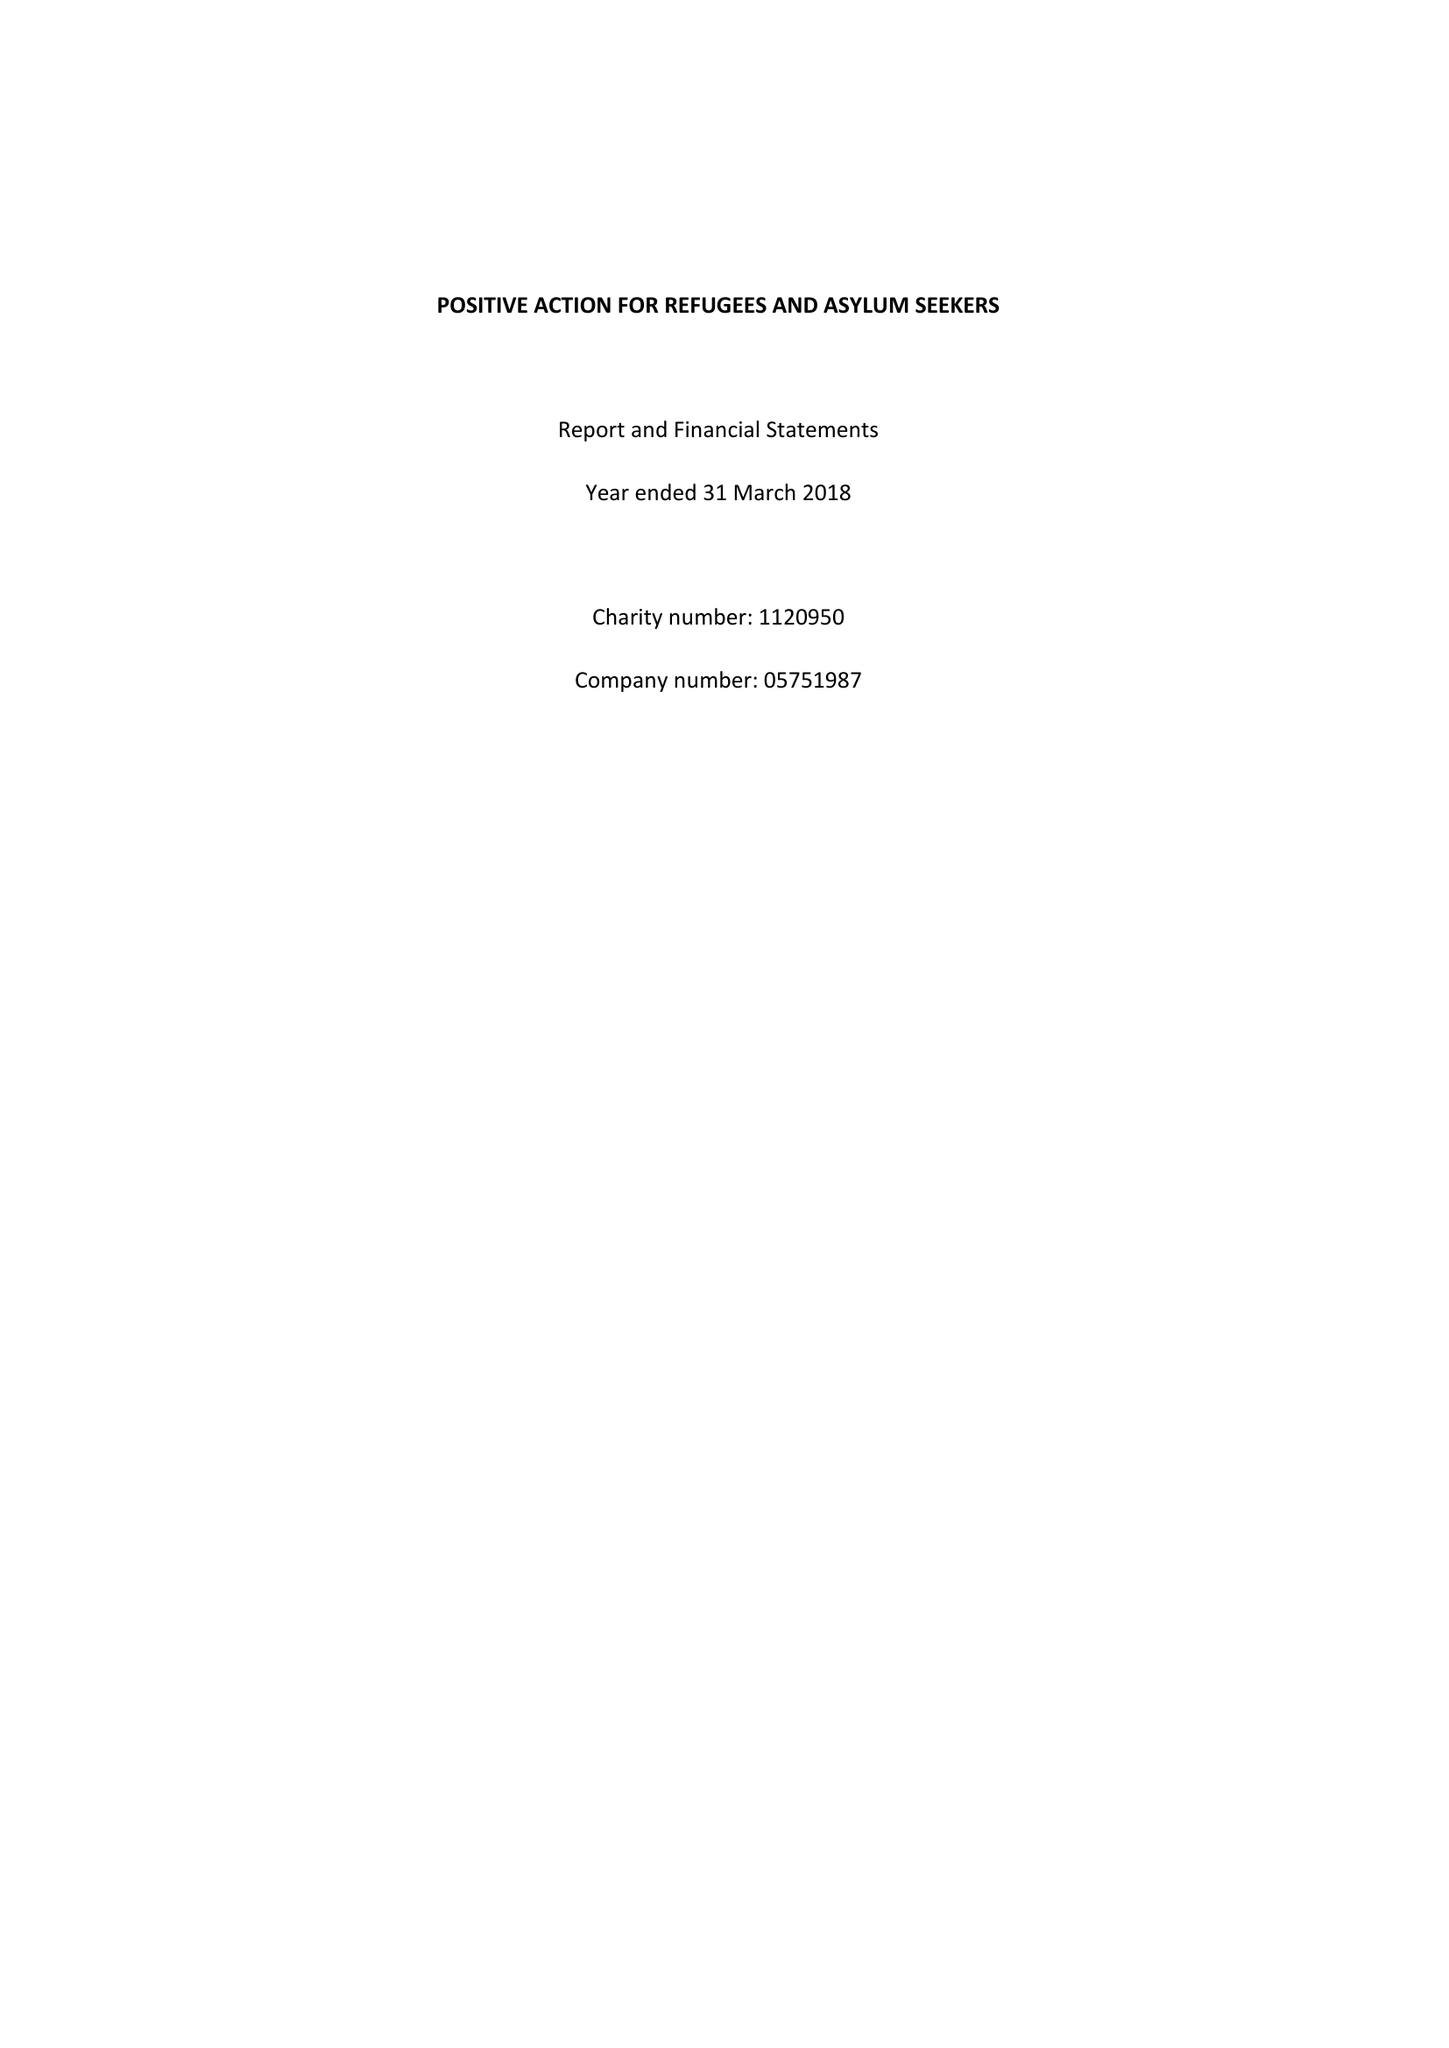What is the value for the income_annually_in_british_pounds?
Answer the question using a single word or phrase. 216693.00 